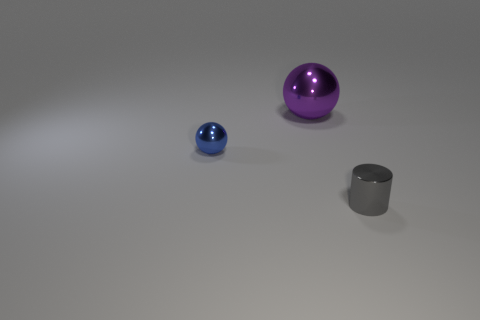Is there any other thing that has the same size as the purple metal thing?
Offer a very short reply. No. What number of large purple metal balls are in front of the tiny shiny thing that is on the left side of the tiny metal thing that is right of the large thing?
Ensure brevity in your answer.  0. What number of other objects are there of the same material as the purple sphere?
Ensure brevity in your answer.  2. Is there a large purple metallic object of the same shape as the blue object?
Give a very brief answer. Yes. There is a thing that is the same size as the shiny cylinder; what is its shape?
Ensure brevity in your answer.  Sphere. What number of tiny metallic things are the same color as the metallic cylinder?
Offer a terse response. 0. There is a shiny thing that is in front of the small metal ball; how big is it?
Offer a very short reply. Small. What number of metallic things have the same size as the purple ball?
Give a very brief answer. 0. What is the color of the cylinder that is made of the same material as the big purple object?
Give a very brief answer. Gray. Is the number of blue things that are right of the metal cylinder less than the number of tiny gray shiny things?
Provide a succinct answer. Yes. 